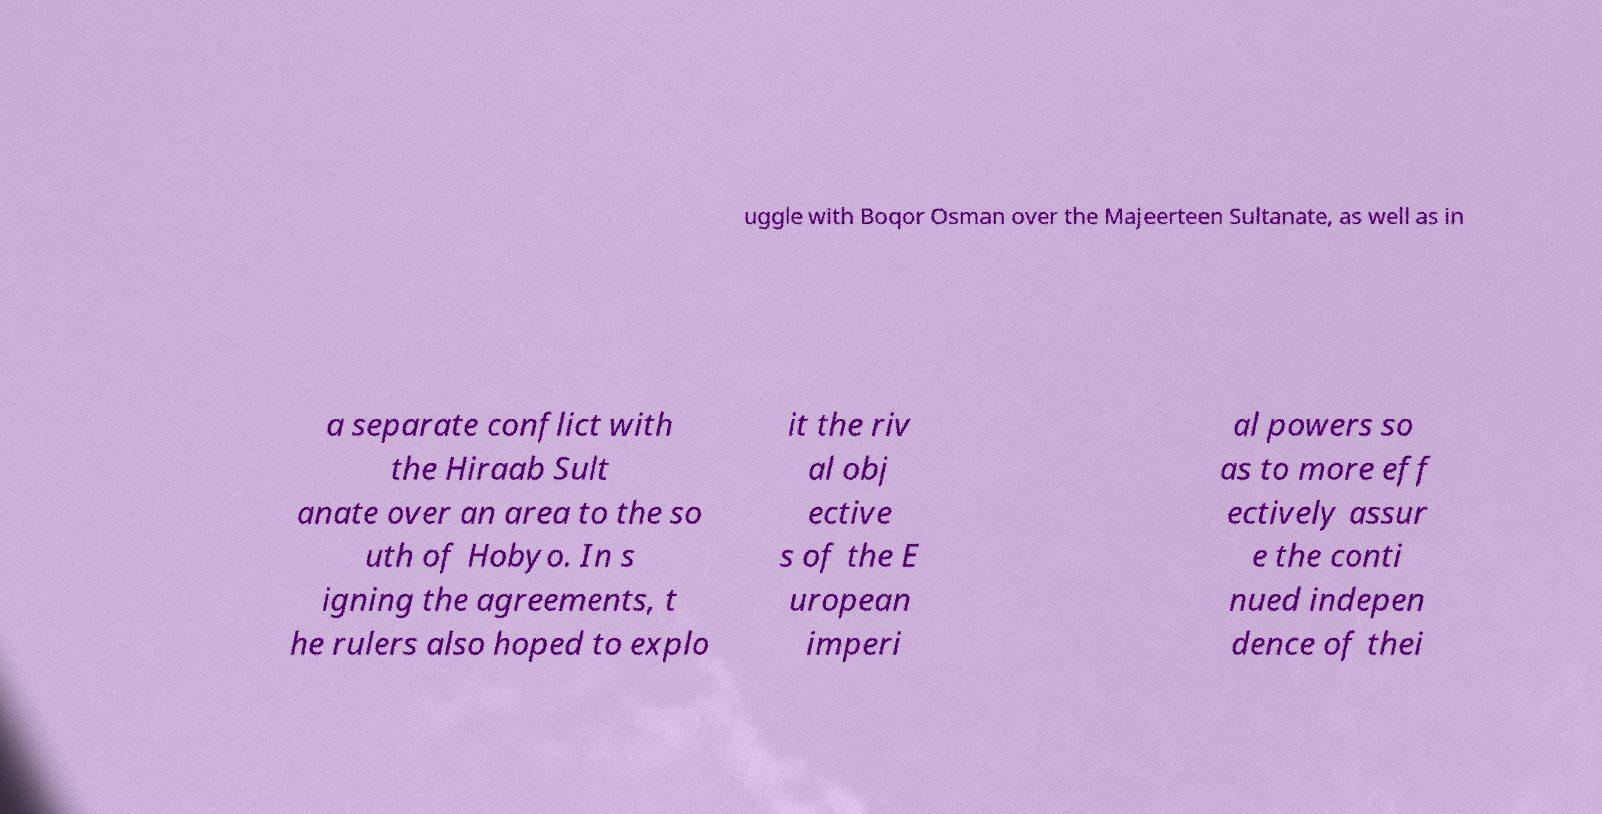What messages or text are displayed in this image? I need them in a readable, typed format. uggle with Boqor Osman over the Majeerteen Sultanate, as well as in a separate conflict with the Hiraab Sult anate over an area to the so uth of Hobyo. In s igning the agreements, t he rulers also hoped to explo it the riv al obj ective s of the E uropean imperi al powers so as to more eff ectively assur e the conti nued indepen dence of thei 